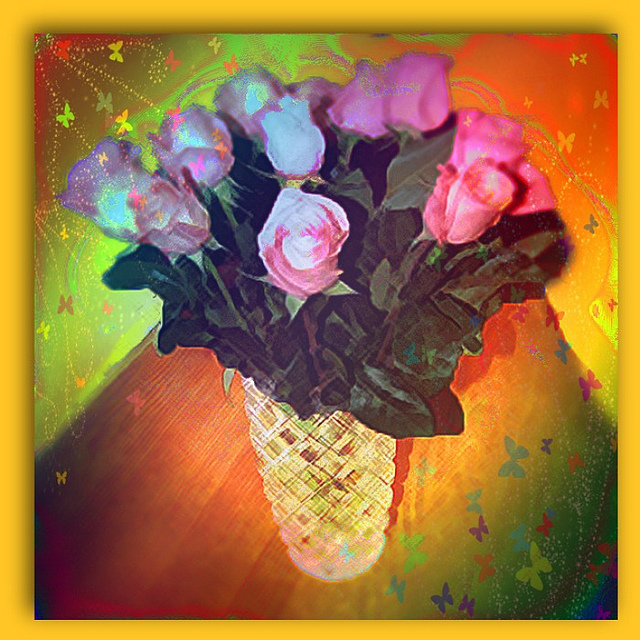What are this flower a symbol of? Often, flowers like the ones shown in the image symbolize a range of emotions and concepts, such as love, beauty, and the fleeting nature of life, but without a specific type of flower or cultural context, it's difficult to assign a definitive meaning. However, given the vibrant and cheerful colors, one could interpret these flowers as a representation of joy or celebration. 